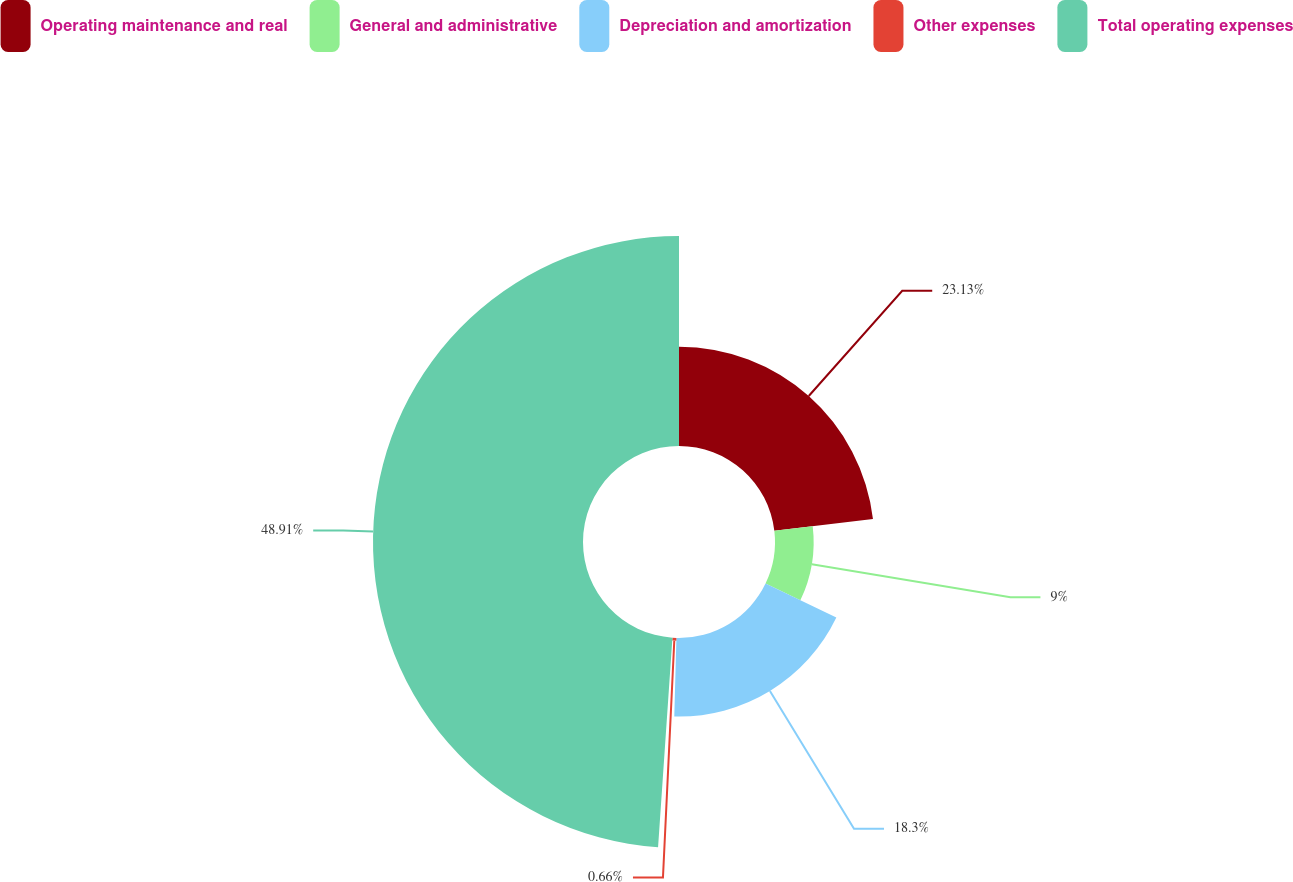Convert chart to OTSL. <chart><loc_0><loc_0><loc_500><loc_500><pie_chart><fcel>Operating maintenance and real<fcel>General and administrative<fcel>Depreciation and amortization<fcel>Other expenses<fcel>Total operating expenses<nl><fcel>23.13%<fcel>9.0%<fcel>18.3%<fcel>0.66%<fcel>48.91%<nl></chart> 